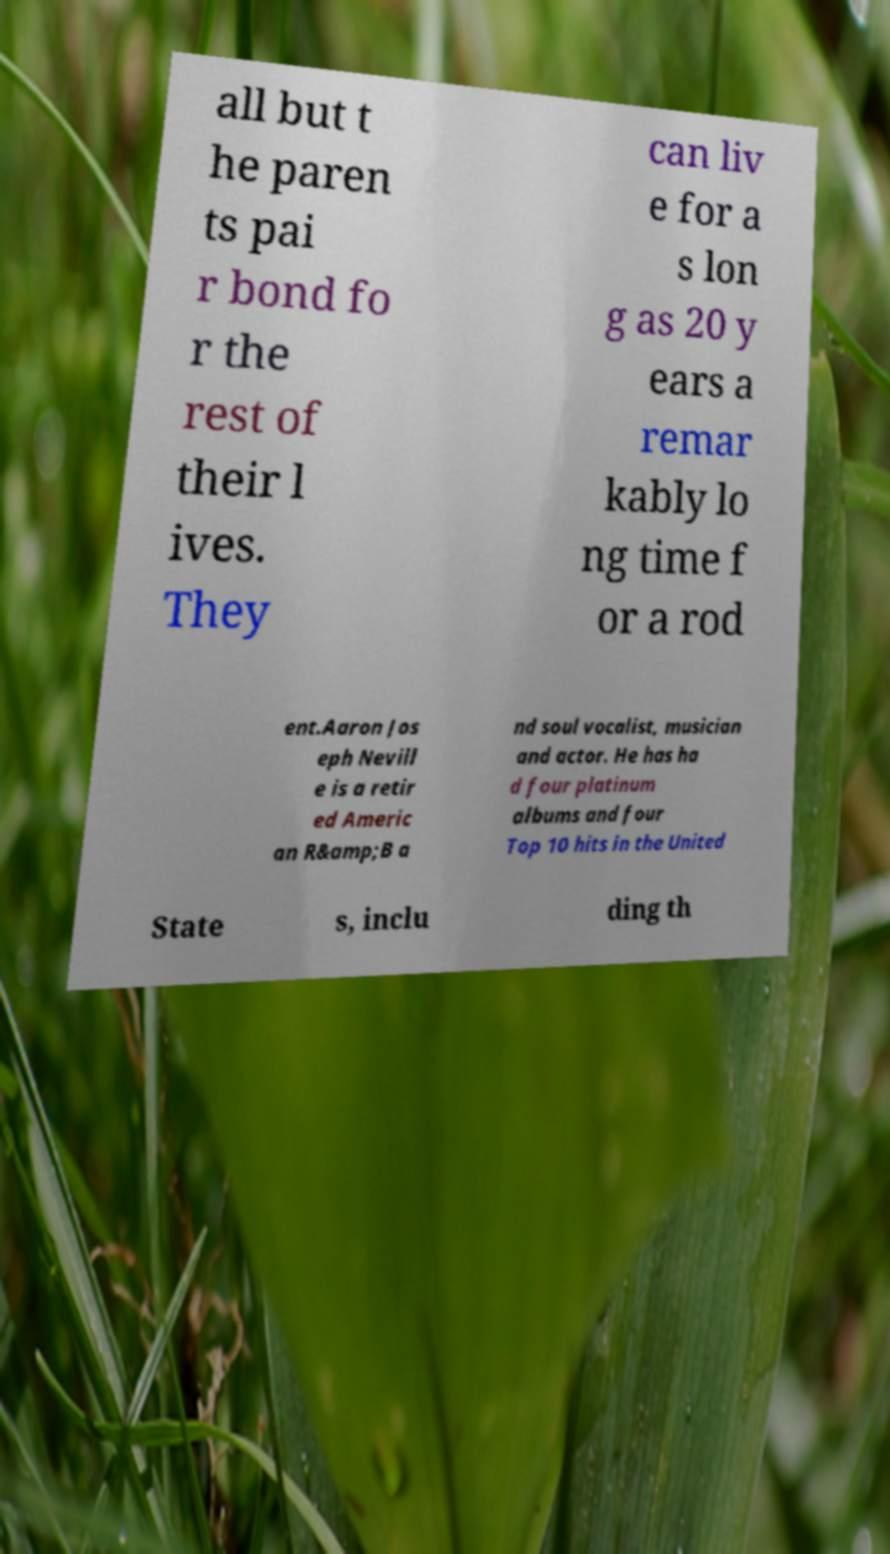I need the written content from this picture converted into text. Can you do that? all but t he paren ts pai r bond fo r the rest of their l ives. They can liv e for a s lon g as 20 y ears a remar kably lo ng time f or a rod ent.Aaron Jos eph Nevill e is a retir ed Americ an R&amp;B a nd soul vocalist, musician and actor. He has ha d four platinum albums and four Top 10 hits in the United State s, inclu ding th 